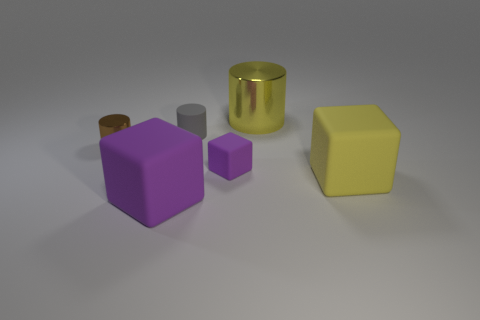Add 3 small objects. How many objects exist? 9 Subtract all blue matte cylinders. Subtract all big purple rubber blocks. How many objects are left? 5 Add 6 metal objects. How many metal objects are left? 8 Add 6 big yellow shiny cylinders. How many big yellow shiny cylinders exist? 7 Subtract 0 cyan cylinders. How many objects are left? 6 